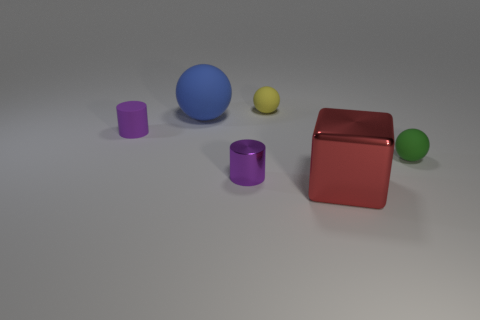Is there any other thing that has the same shape as the red thing?
Make the answer very short. No. There is a purple metal cylinder; are there any big red blocks in front of it?
Keep it short and to the point. Yes. Is the shiny cube the same size as the yellow sphere?
Keep it short and to the point. No. There is a small matte object that is right of the yellow matte object; what shape is it?
Make the answer very short. Sphere. Is there a matte object that has the same size as the yellow rubber sphere?
Provide a short and direct response. Yes. There is a yellow thing that is the same size as the green rubber thing; what is its material?
Your answer should be very brief. Rubber. How big is the object to the right of the red metal cube?
Keep it short and to the point. Small. The blue ball has what size?
Your answer should be compact. Large. Do the red metal block and the ball that is left of the yellow matte sphere have the same size?
Your response must be concise. Yes. The small object behind the small cylinder behind the small green sphere is what color?
Offer a terse response. Yellow. 